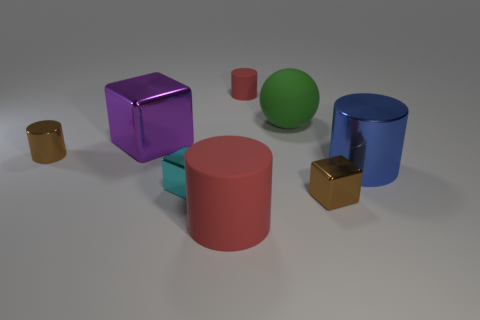There is a metal thing that is on the right side of the small cyan thing and to the left of the big blue shiny cylinder; how big is it?
Offer a terse response. Small. How many red objects are the same material as the sphere?
Your answer should be very brief. 2. There is a shiny object that is the same color as the small shiny cylinder; what is its shape?
Offer a very short reply. Cube. The small matte thing has what color?
Offer a terse response. Red. There is a big rubber object in front of the large green matte thing; is it the same shape as the large green object?
Offer a very short reply. No. What number of objects are either rubber cylinders that are on the left side of the sphere or tiny rubber cylinders?
Provide a short and direct response. 2. Is there a small cyan thing that has the same shape as the blue object?
Your answer should be very brief. No. What shape is the green thing that is the same size as the blue thing?
Give a very brief answer. Sphere. What shape is the large purple object on the left side of the green object right of the metallic cylinder to the left of the large metal cube?
Your response must be concise. Cube. There is a large purple metal thing; is it the same shape as the large matte thing to the left of the big matte sphere?
Your answer should be compact. No. 